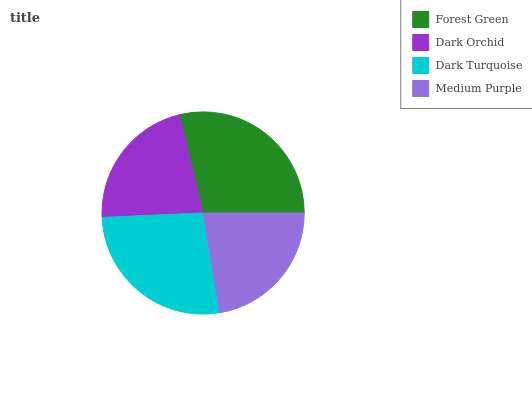Is Dark Orchid the minimum?
Answer yes or no. Yes. Is Forest Green the maximum?
Answer yes or no. Yes. Is Dark Turquoise the minimum?
Answer yes or no. No. Is Dark Turquoise the maximum?
Answer yes or no. No. Is Dark Turquoise greater than Dark Orchid?
Answer yes or no. Yes. Is Dark Orchid less than Dark Turquoise?
Answer yes or no. Yes. Is Dark Orchid greater than Dark Turquoise?
Answer yes or no. No. Is Dark Turquoise less than Dark Orchid?
Answer yes or no. No. Is Dark Turquoise the high median?
Answer yes or no. Yes. Is Medium Purple the low median?
Answer yes or no. Yes. Is Forest Green the high median?
Answer yes or no. No. Is Forest Green the low median?
Answer yes or no. No. 